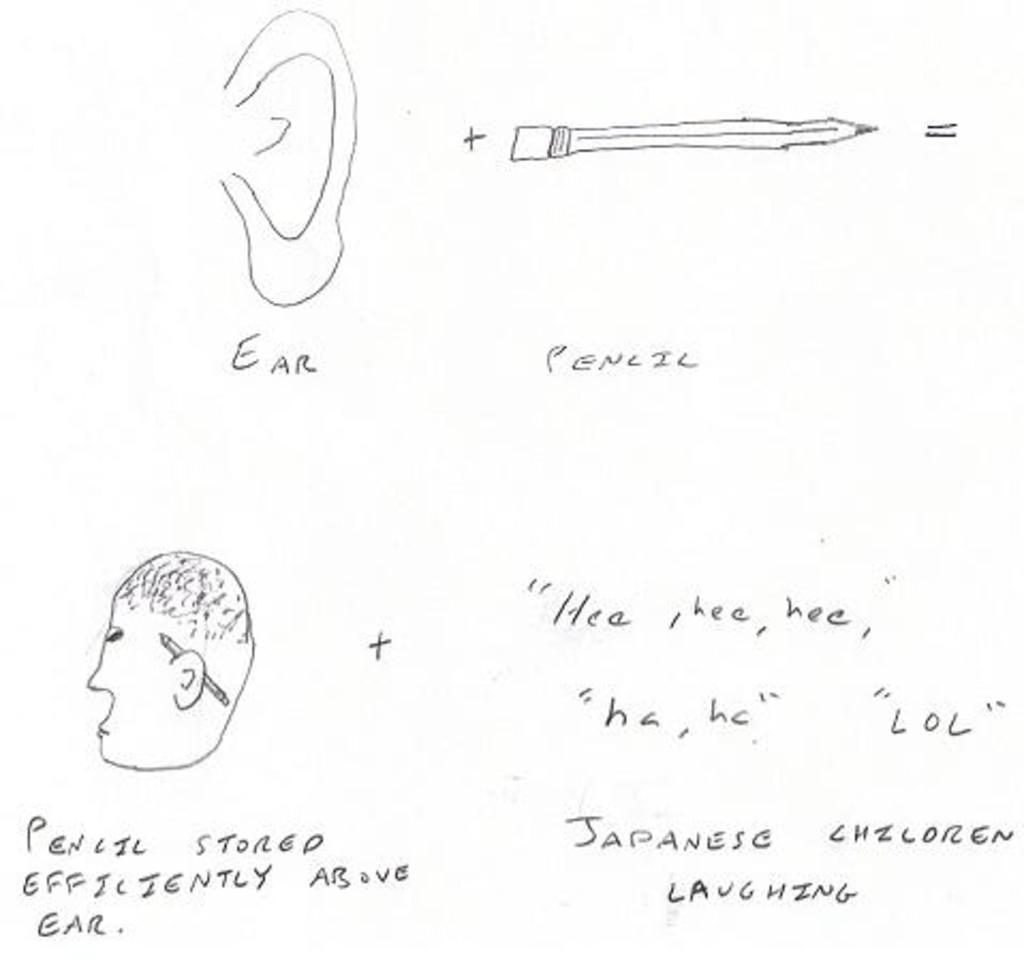Where is the pencil stored?
Your response must be concise. Above ear. What kind of children are laughing?
Give a very brief answer. Japanese. 